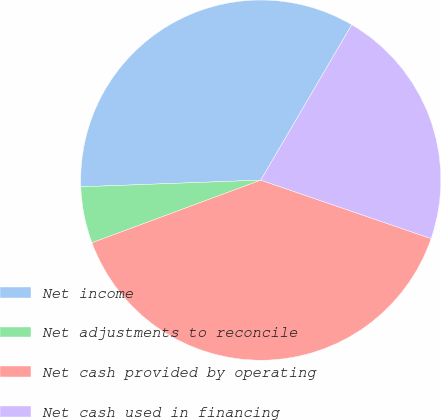Convert chart. <chart><loc_0><loc_0><loc_500><loc_500><pie_chart><fcel>Net income<fcel>Net adjustments to reconcile<fcel>Net cash provided by operating<fcel>Net cash used in financing<nl><fcel>34.02%<fcel>5.06%<fcel>39.08%<fcel>21.83%<nl></chart> 